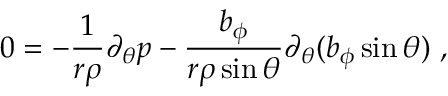Convert formula to latex. <formula><loc_0><loc_0><loc_500><loc_500>0 = - \frac { 1 } { r \rho } \partial _ { \theta } p - \frac { b _ { \phi } } { r \rho \sin \theta } \partial _ { \theta } ( b _ { \phi } \sin \theta ) \ ,</formula> 